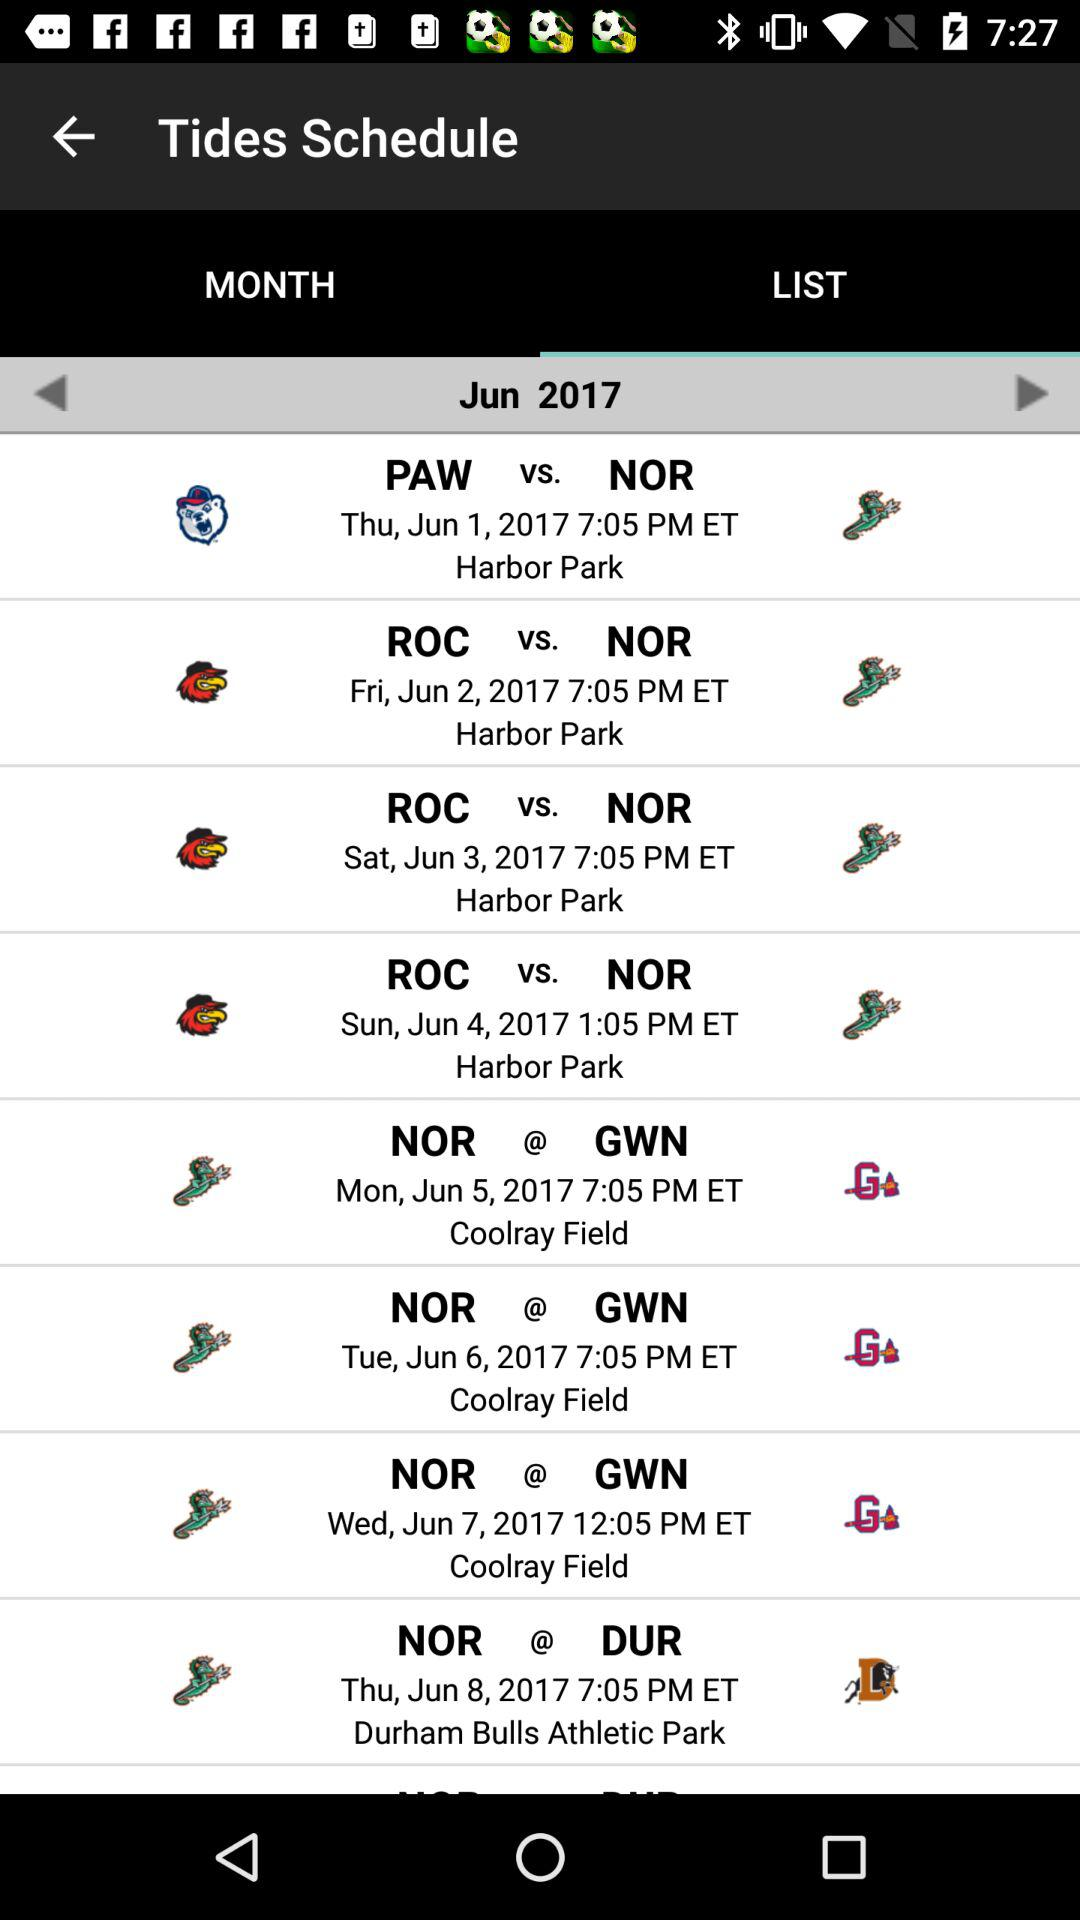On Thursday, June 1, 2017, the match will be played between which two teams? The match will be played between PAW and NOR. 